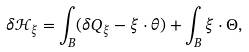<formula> <loc_0><loc_0><loc_500><loc_500>\delta { \mathcal { H } } _ { \xi } = \int _ { B } ( \delta Q _ { \xi } - \xi \cdot \theta ) + \int _ { B } \xi \cdot \Theta ,</formula> 